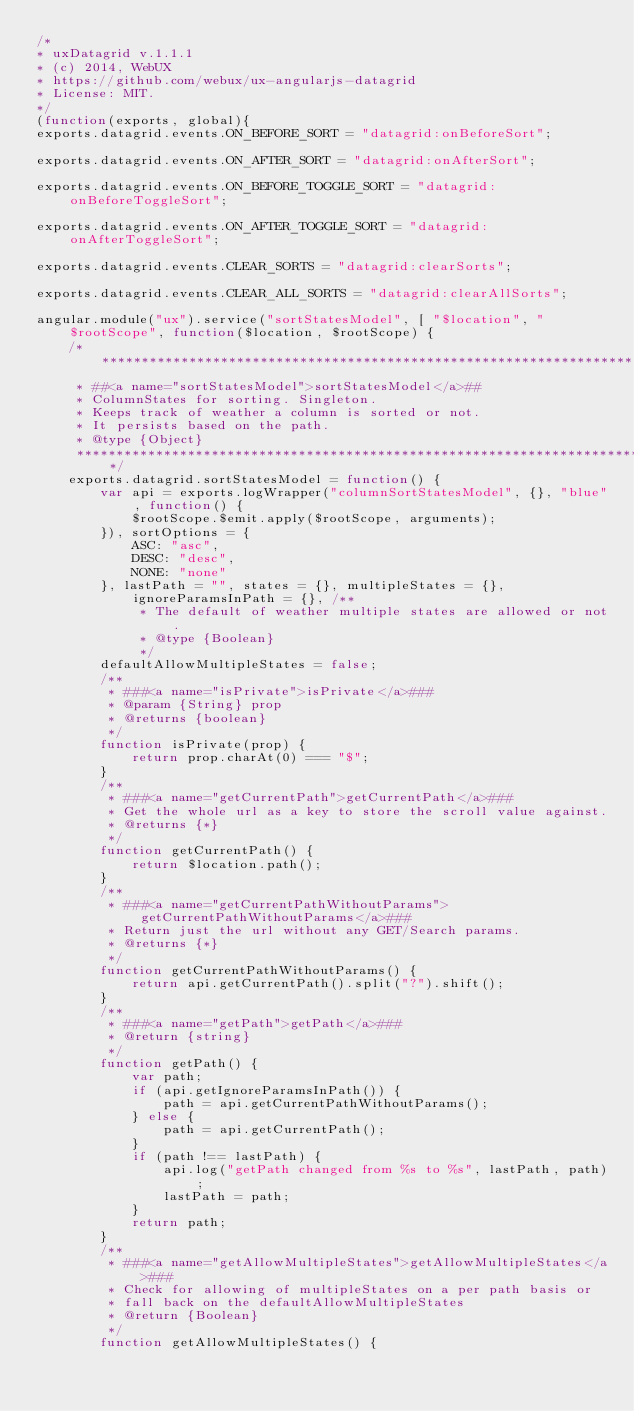<code> <loc_0><loc_0><loc_500><loc_500><_JavaScript_>/*
* uxDatagrid v.1.1.1
* (c) 2014, WebUX
* https://github.com/webux/ux-angularjs-datagrid
* License: MIT.
*/
(function(exports, global){
exports.datagrid.events.ON_BEFORE_SORT = "datagrid:onBeforeSort";

exports.datagrid.events.ON_AFTER_SORT = "datagrid:onAfterSort";

exports.datagrid.events.ON_BEFORE_TOGGLE_SORT = "datagrid:onBeforeToggleSort";

exports.datagrid.events.ON_AFTER_TOGGLE_SORT = "datagrid:onAfterToggleSort";

exports.datagrid.events.CLEAR_SORTS = "datagrid:clearSorts";

exports.datagrid.events.CLEAR_ALL_SORTS = "datagrid:clearAllSorts";

angular.module("ux").service("sortStatesModel", [ "$location", "$rootScope", function($location, $rootScope) {
    /**************************************************************************************
     * ##<a name="sortStatesModel">sortStatesModel</a>##
     * ColumnStates for sorting. Singleton.
     * Keeps track of weather a column is sorted or not.
     * It persists based on the path.
     * @type {Object}
     **************************************************************************************/
    exports.datagrid.sortStatesModel = function() {
        var api = exports.logWrapper("columnSortStatesModel", {}, "blue", function() {
            $rootScope.$emit.apply($rootScope, arguments);
        }), sortOptions = {
            ASC: "asc",
            DESC: "desc",
            NONE: "none"
        }, lastPath = "", states = {}, multipleStates = {}, ignoreParamsInPath = {}, /**
             * The default of weather multiple states are allowed or not.
             * @type {Boolean}
             */
        defaultAllowMultipleStates = false;
        /**
         * ###<a name="isPrivate">isPrivate</a>###
         * @param {String} prop
         * @returns {boolean}
         */
        function isPrivate(prop) {
            return prop.charAt(0) === "$";
        }
        /**
         * ###<a name="getCurrentPath">getCurrentPath</a>###
         * Get the whole url as a key to store the scroll value against.
         * @returns {*}
         */
        function getCurrentPath() {
            return $location.path();
        }
        /**
         * ###<a name="getCurrentPathWithoutParams">getCurrentPathWithoutParams</a>###
         * Return just the url without any GET/Search params.
         * @returns {*}
         */
        function getCurrentPathWithoutParams() {
            return api.getCurrentPath().split("?").shift();
        }
        /**
         * ###<a name="getPath">getPath</a>###
         * @return {string}
         */
        function getPath() {
            var path;
            if (api.getIgnoreParamsInPath()) {
                path = api.getCurrentPathWithoutParams();
            } else {
                path = api.getCurrentPath();
            }
            if (path !== lastPath) {
                api.log("getPath changed from %s to %s", lastPath, path);
                lastPath = path;
            }
            return path;
        }
        /**
         * ###<a name="getAllowMultipleStates">getAllowMultipleStates</a>###
         * Check for allowing of multipleStates on a per path basis or
         * fall back on the defaultAllowMultipleStates
         * @return {Boolean}
         */
        function getAllowMultipleStates() {</code> 